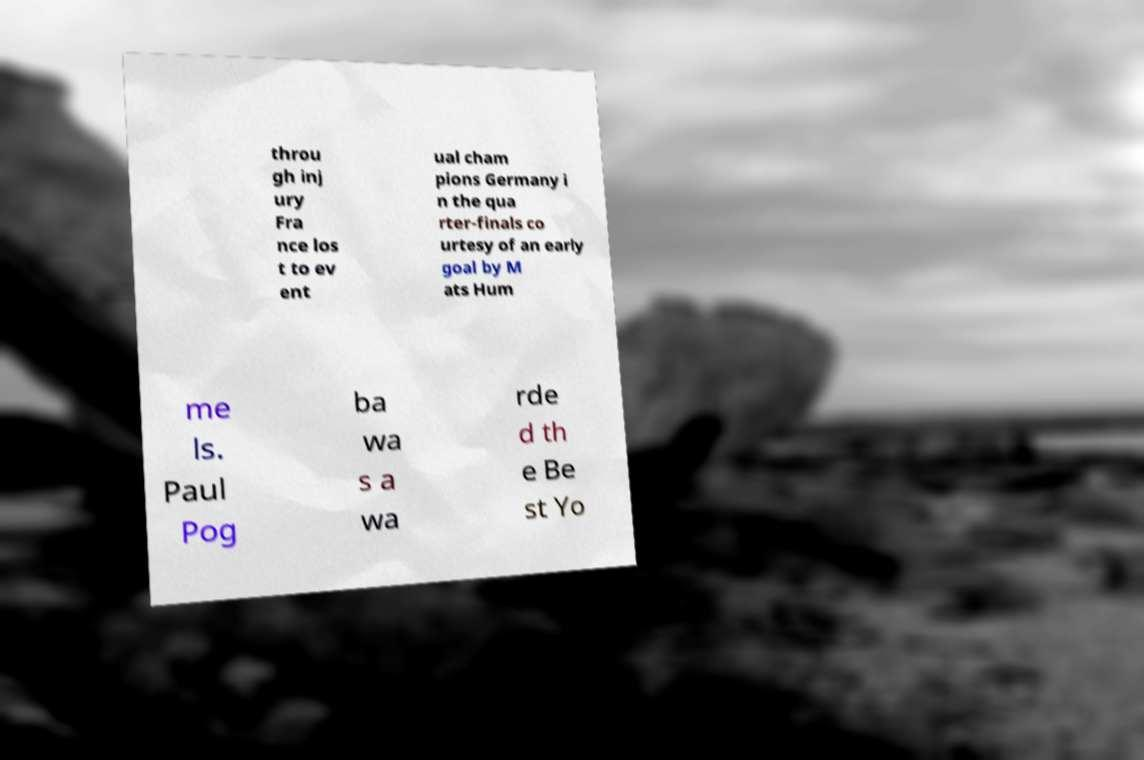What messages or text are displayed in this image? I need them in a readable, typed format. throu gh inj ury Fra nce los t to ev ent ual cham pions Germany i n the qua rter-finals co urtesy of an early goal by M ats Hum me ls. Paul Pog ba wa s a wa rde d th e Be st Yo 